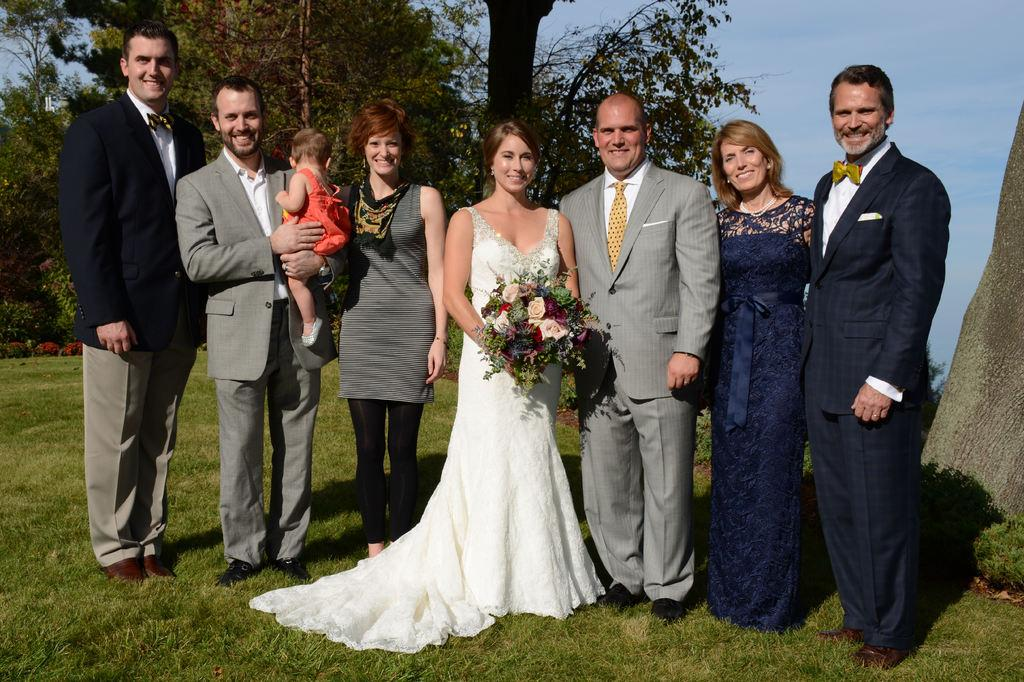What can be seen in the front of the image? There are people standing in the front of the image. What type of vegetation is present in the image? There is grass and trees in the image. What is visible at the top of the image? The sky is visible at the top of the image. What is the woman holding in the image? The woman is holding a bouquet. What type of ink is being used by the queen in the image? There is no queen present in the image, and therefore no ink usage can be observed. What is the woman's hope for the future, as depicted in the image? The image does not provide any information about the woman's hopes for the future. 